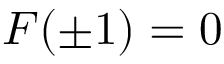<formula> <loc_0><loc_0><loc_500><loc_500>F ( \pm 1 ) = 0</formula> 